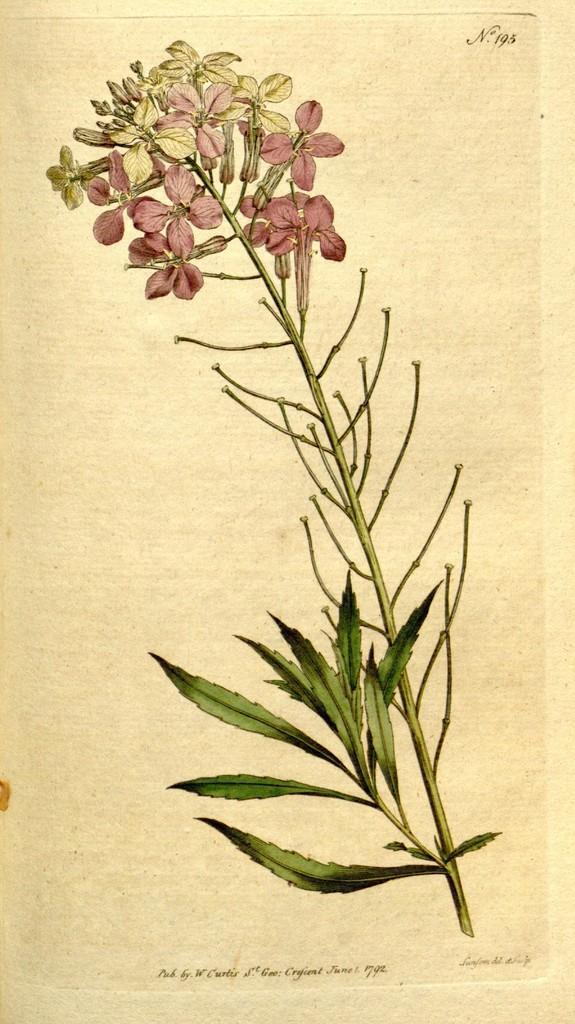How would you summarize this image in a sentence or two? In this image, we can see a branch contains leafs and flowers. 